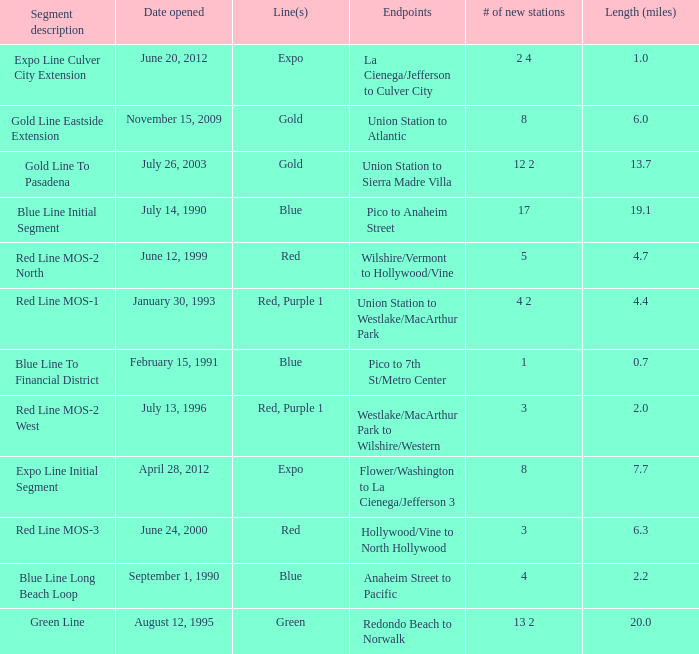Write the full table. {'header': ['Segment description', 'Date opened', 'Line(s)', 'Endpoints', '# of new stations', 'Length (miles)'], 'rows': [['Expo Line Culver City Extension', 'June 20, 2012', 'Expo', 'La Cienega/Jefferson to Culver City', '2 4', '1.0'], ['Gold Line Eastside Extension', 'November 15, 2009', 'Gold', 'Union Station to Atlantic', '8', '6.0'], ['Gold Line To Pasadena', 'July 26, 2003', 'Gold', 'Union Station to Sierra Madre Villa', '12 2', '13.7'], ['Blue Line Initial Segment', 'July 14, 1990', 'Blue', 'Pico to Anaheim Street', '17', '19.1'], ['Red Line MOS-2 North', 'June 12, 1999', 'Red', 'Wilshire/Vermont to Hollywood/Vine', '5', '4.7'], ['Red Line MOS-1', 'January 30, 1993', 'Red, Purple 1', 'Union Station to Westlake/MacArthur Park', '4 2', '4.4'], ['Blue Line To Financial District', 'February 15, 1991', 'Blue', 'Pico to 7th St/Metro Center', '1', '0.7'], ['Red Line MOS-2 West', 'July 13, 1996', 'Red, Purple 1', 'Westlake/MacArthur Park to Wilshire/Western', '3', '2.0'], ['Expo Line Initial Segment', 'April 28, 2012', 'Expo', 'Flower/Washington to La Cienega/Jefferson 3', '8', '7.7'], ['Red Line MOS-3', 'June 24, 2000', 'Red', 'Hollywood/Vine to North Hollywood', '3', '6.3'], ['Blue Line Long Beach Loop', 'September 1, 1990', 'Blue', 'Anaheim Street to Pacific', '4', '2.2'], ['Green Line', 'August 12, 1995', 'Green', 'Redondo Beach to Norwalk', '13 2', '20.0']]} How many lines have the segment description of red line mos-2 west? Red, Purple 1. 